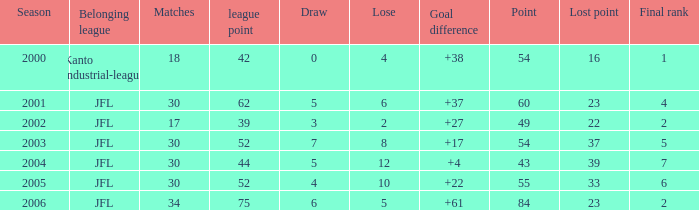Reveal the maximum matches for point 43 and last standing less than None. 